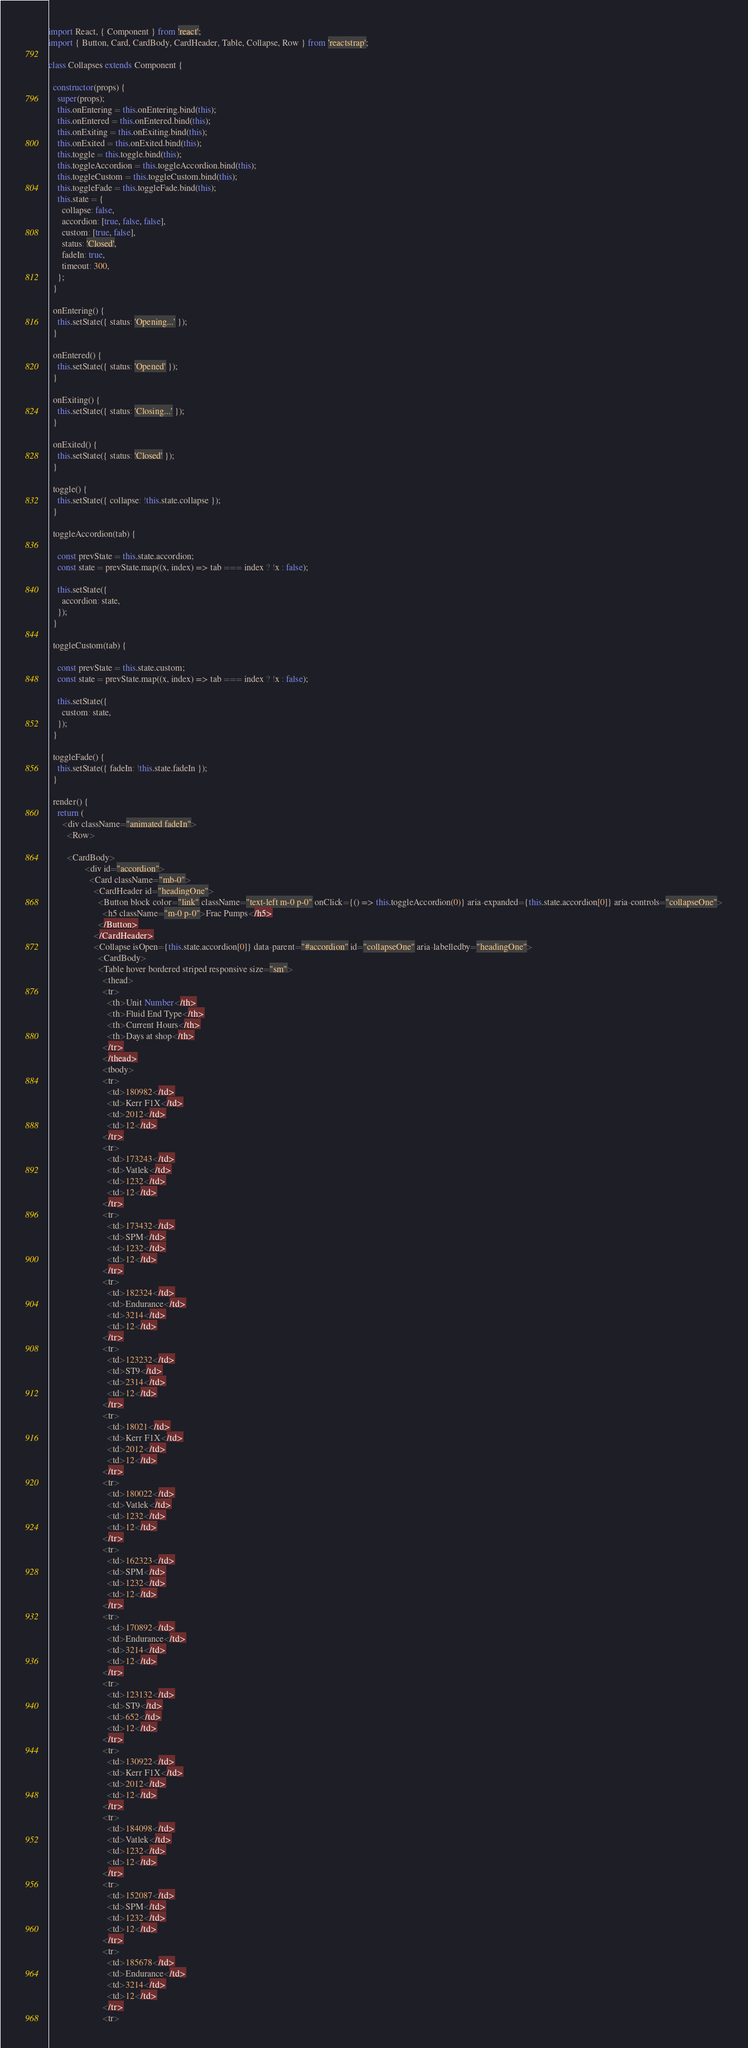<code> <loc_0><loc_0><loc_500><loc_500><_JavaScript_>import React, { Component } from 'react';
import { Button, Card, CardBody, CardHeader, Table, Collapse, Row } from 'reactstrap';

class Collapses extends Component {

  constructor(props) {
    super(props);
    this.onEntering = this.onEntering.bind(this);
    this.onEntered = this.onEntered.bind(this);
    this.onExiting = this.onExiting.bind(this);
    this.onExited = this.onExited.bind(this);
    this.toggle = this.toggle.bind(this);
    this.toggleAccordion = this.toggleAccordion.bind(this);
    this.toggleCustom = this.toggleCustom.bind(this);
    this.toggleFade = this.toggleFade.bind(this);
    this.state = {
      collapse: false,
      accordion: [true, false, false],
      custom: [true, false],
      status: 'Closed',
      fadeIn: true,
      timeout: 300,
    };
  }

  onEntering() {
    this.setState({ status: 'Opening...' });
  }

  onEntered() {
    this.setState({ status: 'Opened' });
  }

  onExiting() {
    this.setState({ status: 'Closing...' });
  }

  onExited() {
    this.setState({ status: 'Closed' });
  }

  toggle() {
    this.setState({ collapse: !this.state.collapse });
  }

  toggleAccordion(tab) {

    const prevState = this.state.accordion;
    const state = prevState.map((x, index) => tab === index ? !x : false);

    this.setState({
      accordion: state,
    });
  }

  toggleCustom(tab) {

    const prevState = this.state.custom;
    const state = prevState.map((x, index) => tab === index ? !x : false);

    this.setState({
      custom: state,
    });
  }

  toggleFade() {
    this.setState({ fadeIn: !this.state.fadeIn });
  }

  render() {
    return (
      <div className="animated fadeIn">
        <Row>

        <CardBody>
                <div id="accordion">
                  <Card className="mb-0">
                    <CardHeader id="headingOne">
                      <Button block color="link" className="text-left m-0 p-0" onClick={() => this.toggleAccordion(0)} aria-expanded={this.state.accordion[0]} aria-controls="collapseOne">
                        <h5 className="m-0 p-0">Frac Pumps</h5>
                      </Button>
                    </CardHeader>
                    <Collapse isOpen={this.state.accordion[0]} data-parent="#accordion" id="collapseOne" aria-labelledby="headingOne">
                      <CardBody>
                      <Table hover bordered striped responsive size="sm">
                        <thead>
                        <tr>
                          <th>Unit Number</th>
                          <th>Fluid End Type</th>
                          <th>Current Hours</th>
                          <th>Days at shop</th>
                        </tr>
                        </thead>
                        <tbody>
                        <tr>
                          <td>180982</td>
                          <td>Kerr F1X</td>
                          <td>2012</td>
                          <td>12</td>
                        </tr>
                        <tr>
                          <td>173243</td>
                          <td>Vatlek</td>
                          <td>1232</td>
                          <td>12</td>
                        </tr>
                        <tr>
                          <td>173432</td>
                          <td>SPM</td>
                          <td>1232</td>
                          <td>12</td>
                        </tr>
                        <tr>
                          <td>182324</td>
                          <td>Endurance</td>
                          <td>3214</td>
                          <td>12</td>
                        </tr>
                        <tr>
                          <td>123232</td>
                          <td>ST9</td>
                          <td>2314</td>
                          <td>12</td>
                        </tr>
                        <tr>
                          <td>18021</td>
                          <td>Kerr F1X</td>
                          <td>2012</td>
                          <td>12</td>
                        </tr>
                        <tr>
                          <td>180022</td>
                          <td>Vatlek</td>
                          <td>1232</td>
                          <td>12</td>
                        </tr>
                        <tr>
                          <td>162323</td>
                          <td>SPM</td>
                          <td>1232</td>
                          <td>12</td>
                        </tr>
                        <tr>
                          <td>170892</td>
                          <td>Endurance</td>
                          <td>3214</td>
                          <td>12</td>
                        </tr>
                        <tr>
                          <td>123132</td>
                          <td>ST9</td>
                          <td>652</td>
                          <td>12</td>
                        </tr>
                        <tr>
                          <td>130922</td>
                          <td>Kerr F1X</td>
                          <td>2012</td>
                          <td>12</td>
                        </tr>
                        <tr>
                          <td>184098</td>
                          <td>Vatlek</td>
                          <td>1232</td>
                          <td>12</td>
                        </tr>
                        <tr>
                          <td>152087</td>
                          <td>SPM</td>
                          <td>1232</td>
                          <td>12</td>
                        </tr>
                        <tr>
                          <td>185678</td>
                          <td>Endurance</td>
                          <td>3214</td>
                          <td>12</td>
                        </tr>
                        <tr></code> 